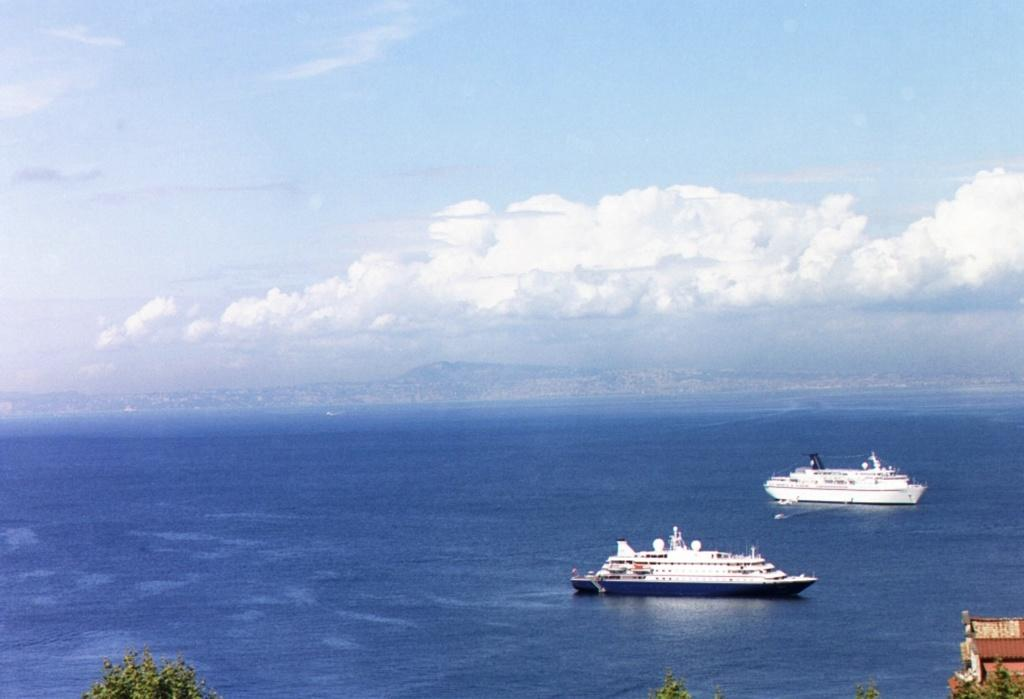What is the main subject of the image? The main subject of the image is ships. Where are the ships located? The ships are in an ocean. What type of vegetation can be seen in the image? There are trees visible in the image. What is the condition of the sky in the image? The sky is clouded in the image. How many centimeters tall is the crown on the ship's captain in the image? There is no crown visible on a ship's captain in the image, and therefore no height can be determined. 